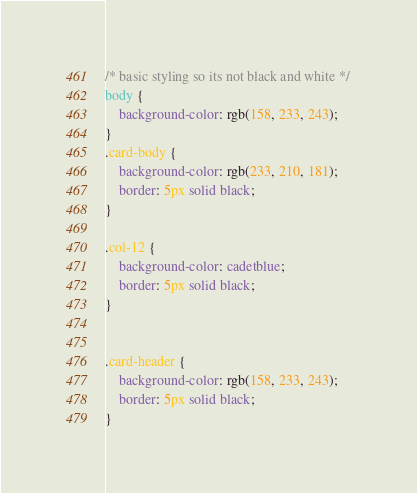<code> <loc_0><loc_0><loc_500><loc_500><_CSS_>/* basic styling so its not black and white */
body {
    background-color: rgb(158, 233, 243);
}
.card-body {
    background-color: rgb(233, 210, 181);
    border: 5px solid black;
}

.col-12 {
    background-color: cadetblue;
    border: 5px solid black;
}
    

.card-header {
    background-color: rgb(158, 233, 243);
    border: 5px solid black;
}</code> 